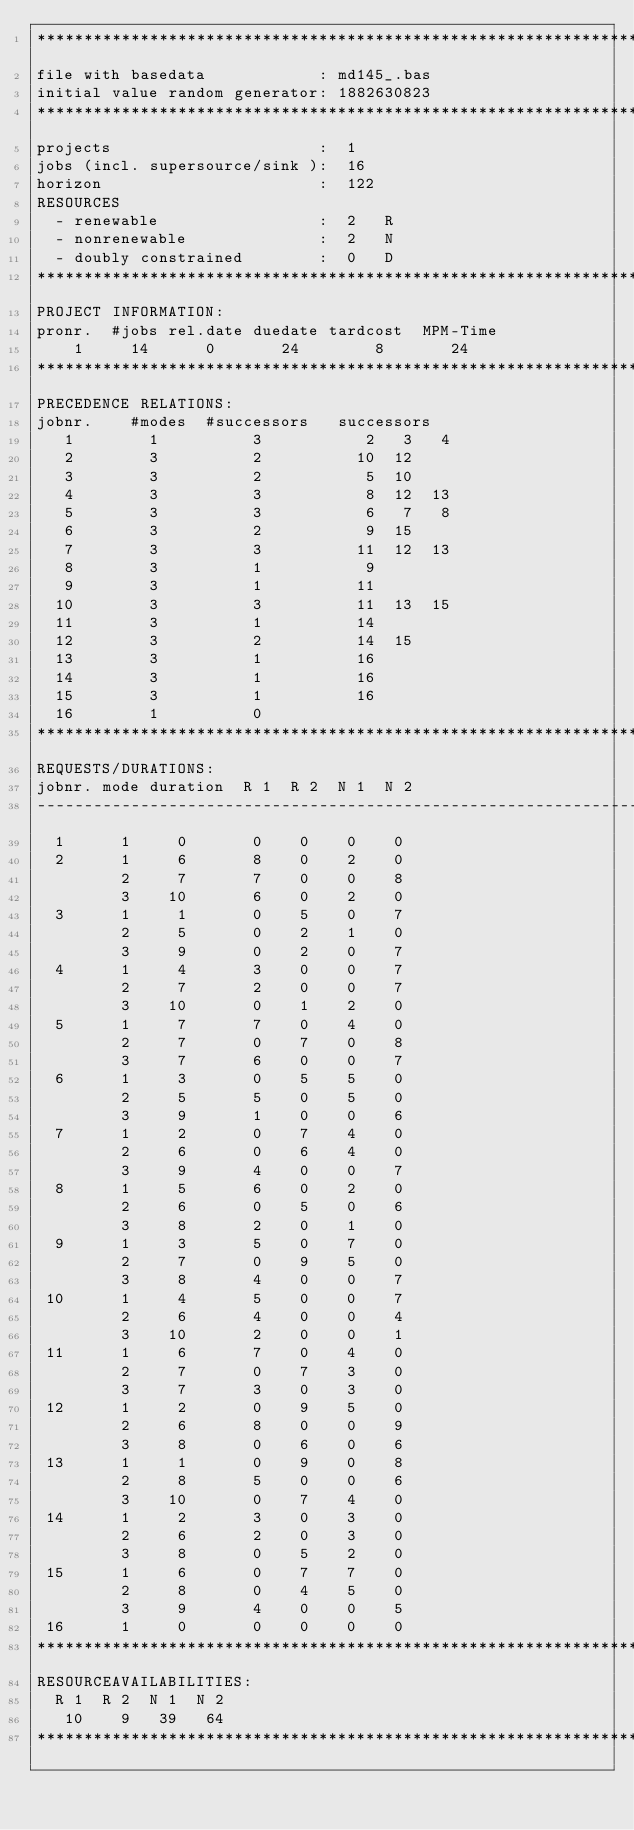Convert code to text. <code><loc_0><loc_0><loc_500><loc_500><_ObjectiveC_>************************************************************************
file with basedata            : md145_.bas
initial value random generator: 1882630823
************************************************************************
projects                      :  1
jobs (incl. supersource/sink ):  16
horizon                       :  122
RESOURCES
  - renewable                 :  2   R
  - nonrenewable              :  2   N
  - doubly constrained        :  0   D
************************************************************************
PROJECT INFORMATION:
pronr.  #jobs rel.date duedate tardcost  MPM-Time
    1     14      0       24        8       24
************************************************************************
PRECEDENCE RELATIONS:
jobnr.    #modes  #successors   successors
   1        1          3           2   3   4
   2        3          2          10  12
   3        3          2           5  10
   4        3          3           8  12  13
   5        3          3           6   7   8
   6        3          2           9  15
   7        3          3          11  12  13
   8        3          1           9
   9        3          1          11
  10        3          3          11  13  15
  11        3          1          14
  12        3          2          14  15
  13        3          1          16
  14        3          1          16
  15        3          1          16
  16        1          0        
************************************************************************
REQUESTS/DURATIONS:
jobnr. mode duration  R 1  R 2  N 1  N 2
------------------------------------------------------------------------
  1      1     0       0    0    0    0
  2      1     6       8    0    2    0
         2     7       7    0    0    8
         3    10       6    0    2    0
  3      1     1       0    5    0    7
         2     5       0    2    1    0
         3     9       0    2    0    7
  4      1     4       3    0    0    7
         2     7       2    0    0    7
         3    10       0    1    2    0
  5      1     7       7    0    4    0
         2     7       0    7    0    8
         3     7       6    0    0    7
  6      1     3       0    5    5    0
         2     5       5    0    5    0
         3     9       1    0    0    6
  7      1     2       0    7    4    0
         2     6       0    6    4    0
         3     9       4    0    0    7
  8      1     5       6    0    2    0
         2     6       0    5    0    6
         3     8       2    0    1    0
  9      1     3       5    0    7    0
         2     7       0    9    5    0
         3     8       4    0    0    7
 10      1     4       5    0    0    7
         2     6       4    0    0    4
         3    10       2    0    0    1
 11      1     6       7    0    4    0
         2     7       0    7    3    0
         3     7       3    0    3    0
 12      1     2       0    9    5    0
         2     6       8    0    0    9
         3     8       0    6    0    6
 13      1     1       0    9    0    8
         2     8       5    0    0    6
         3    10       0    7    4    0
 14      1     2       3    0    3    0
         2     6       2    0    3    0
         3     8       0    5    2    0
 15      1     6       0    7    7    0
         2     8       0    4    5    0
         3     9       4    0    0    5
 16      1     0       0    0    0    0
************************************************************************
RESOURCEAVAILABILITIES:
  R 1  R 2  N 1  N 2
   10    9   39   64
************************************************************************
</code> 